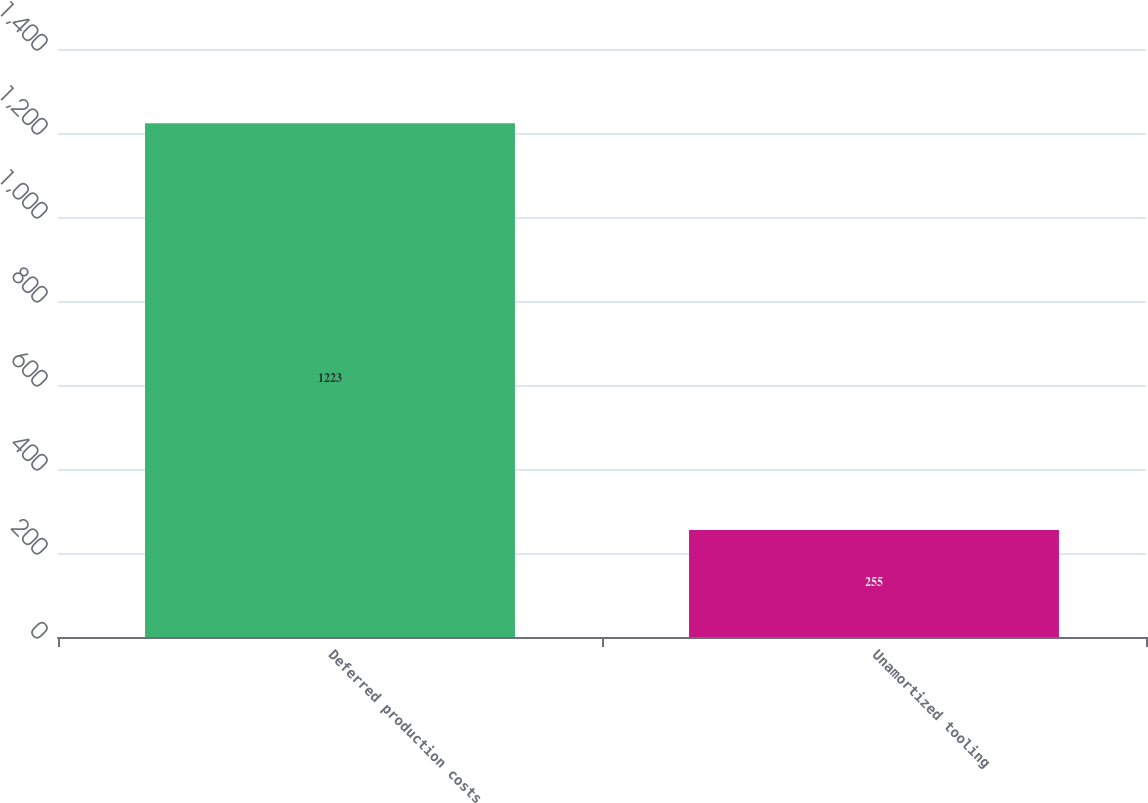Convert chart. <chart><loc_0><loc_0><loc_500><loc_500><bar_chart><fcel>Deferred production costs<fcel>Unamortized tooling<nl><fcel>1223<fcel>255<nl></chart> 